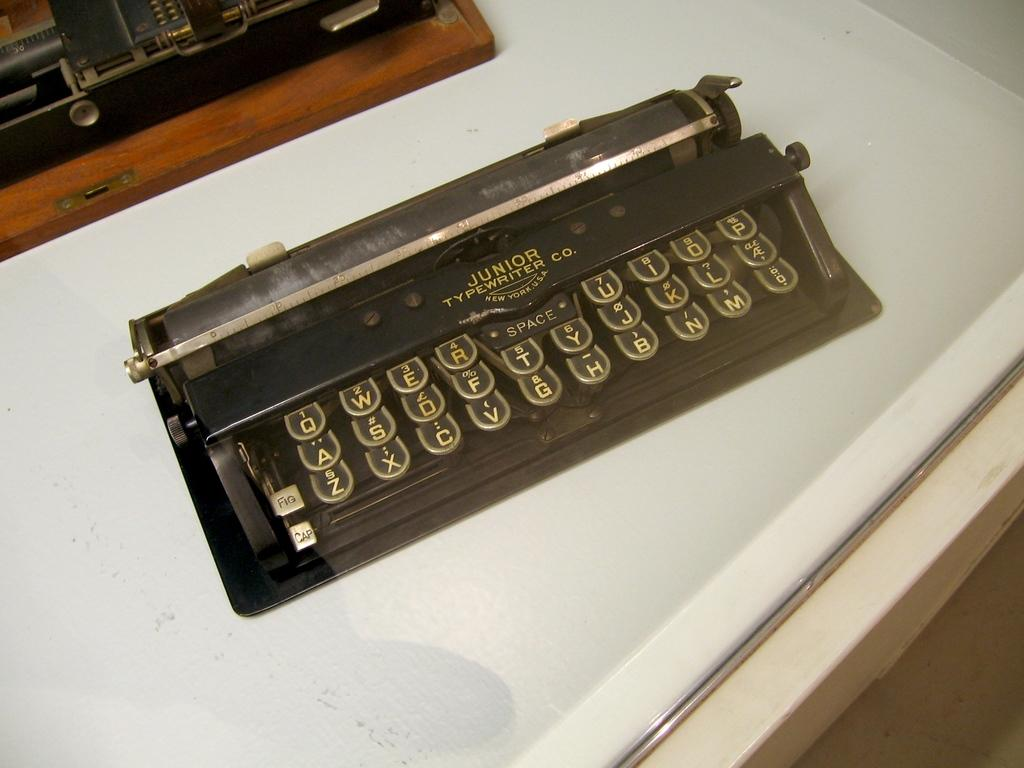<image>
Present a compact description of the photo's key features. A vintage keyboard from the Junior Typewriter Co sits on a table. 